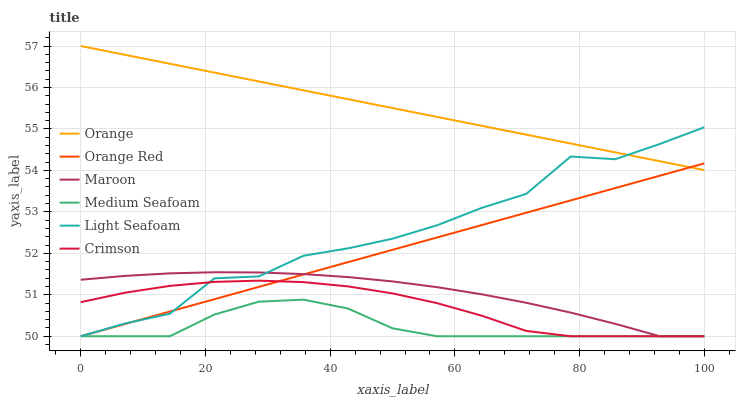Does Medium Seafoam have the minimum area under the curve?
Answer yes or no. Yes. Does Orange have the maximum area under the curve?
Answer yes or no. Yes. Does Crimson have the minimum area under the curve?
Answer yes or no. No. Does Crimson have the maximum area under the curve?
Answer yes or no. No. Is Orange the smoothest?
Answer yes or no. Yes. Is Light Seafoam the roughest?
Answer yes or no. Yes. Is Medium Seafoam the smoothest?
Answer yes or no. No. Is Medium Seafoam the roughest?
Answer yes or no. No. Does Maroon have the lowest value?
Answer yes or no. Yes. Does Orange have the lowest value?
Answer yes or no. No. Does Orange have the highest value?
Answer yes or no. Yes. Does Crimson have the highest value?
Answer yes or no. No. Is Maroon less than Orange?
Answer yes or no. Yes. Is Orange greater than Crimson?
Answer yes or no. Yes. Does Light Seafoam intersect Medium Seafoam?
Answer yes or no. Yes. Is Light Seafoam less than Medium Seafoam?
Answer yes or no. No. Is Light Seafoam greater than Medium Seafoam?
Answer yes or no. No. Does Maroon intersect Orange?
Answer yes or no. No. 